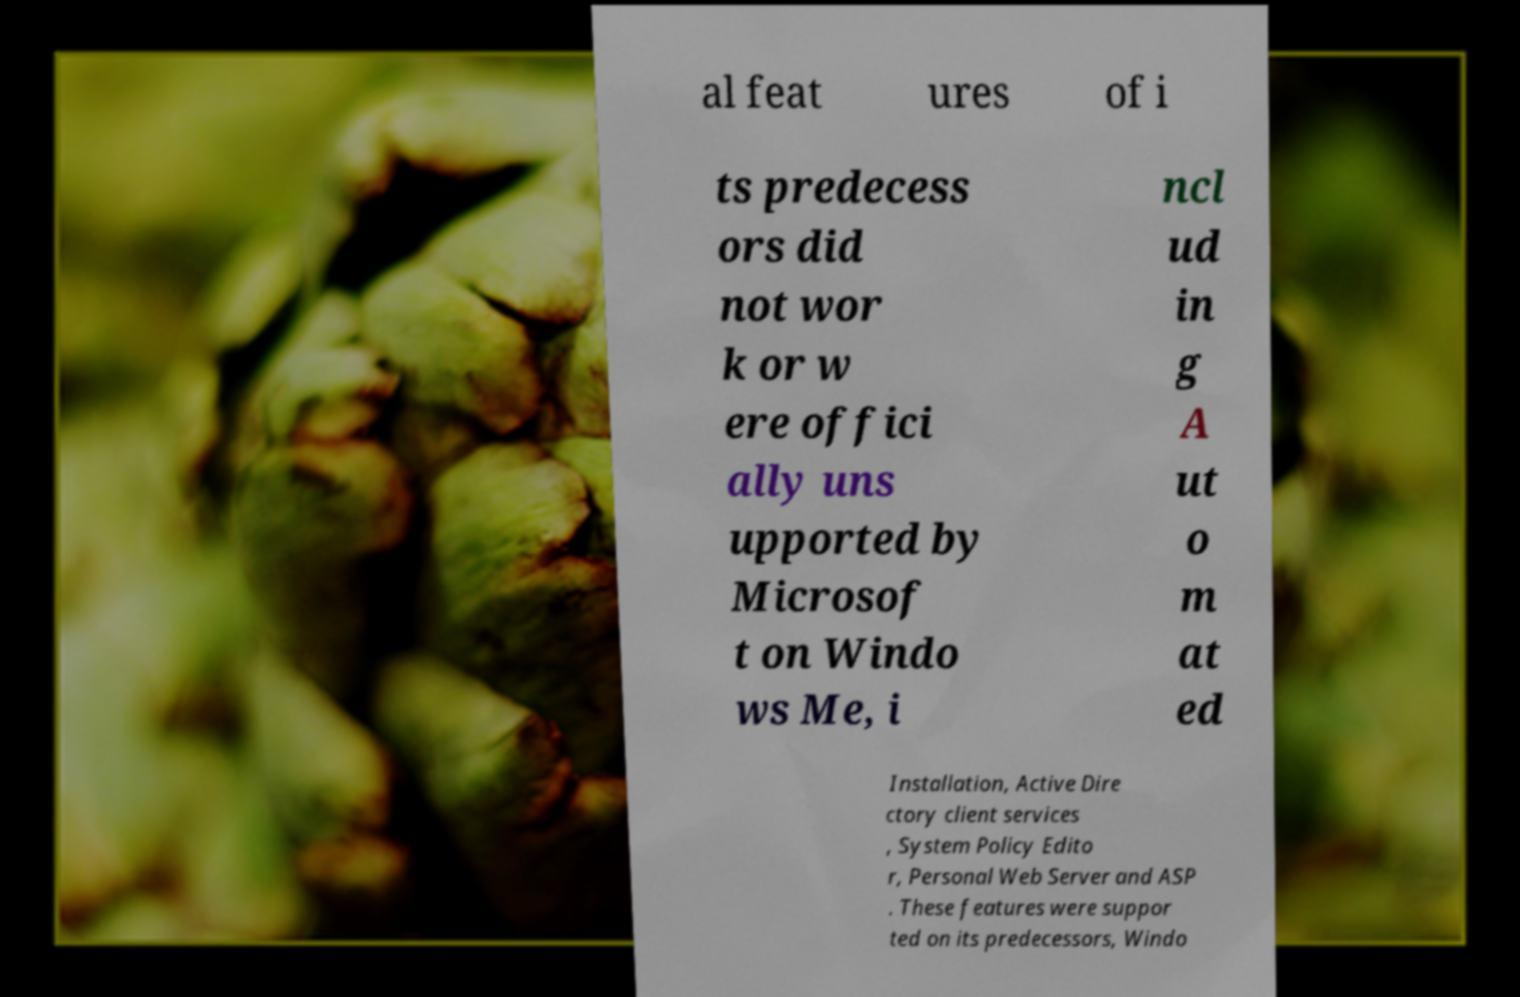Can you accurately transcribe the text from the provided image for me? al feat ures of i ts predecess ors did not wor k or w ere offici ally uns upported by Microsof t on Windo ws Me, i ncl ud in g A ut o m at ed Installation, Active Dire ctory client services , System Policy Edito r, Personal Web Server and ASP . These features were suppor ted on its predecessors, Windo 